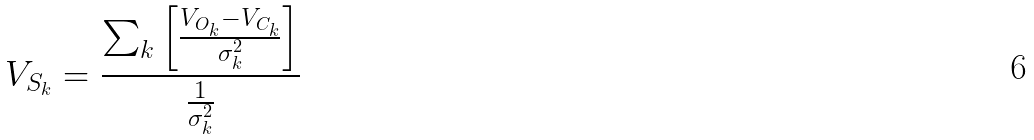Convert formula to latex. <formula><loc_0><loc_0><loc_500><loc_500>V _ { S _ { k } } = \frac { \sum _ { k } \left [ \frac { V _ { O _ { k } } - V _ { C _ { k } } } { \sigma _ { k } ^ { 2 } } \right ] } { \frac { 1 } { \sigma _ { k } ^ { 2 } } }</formula> 